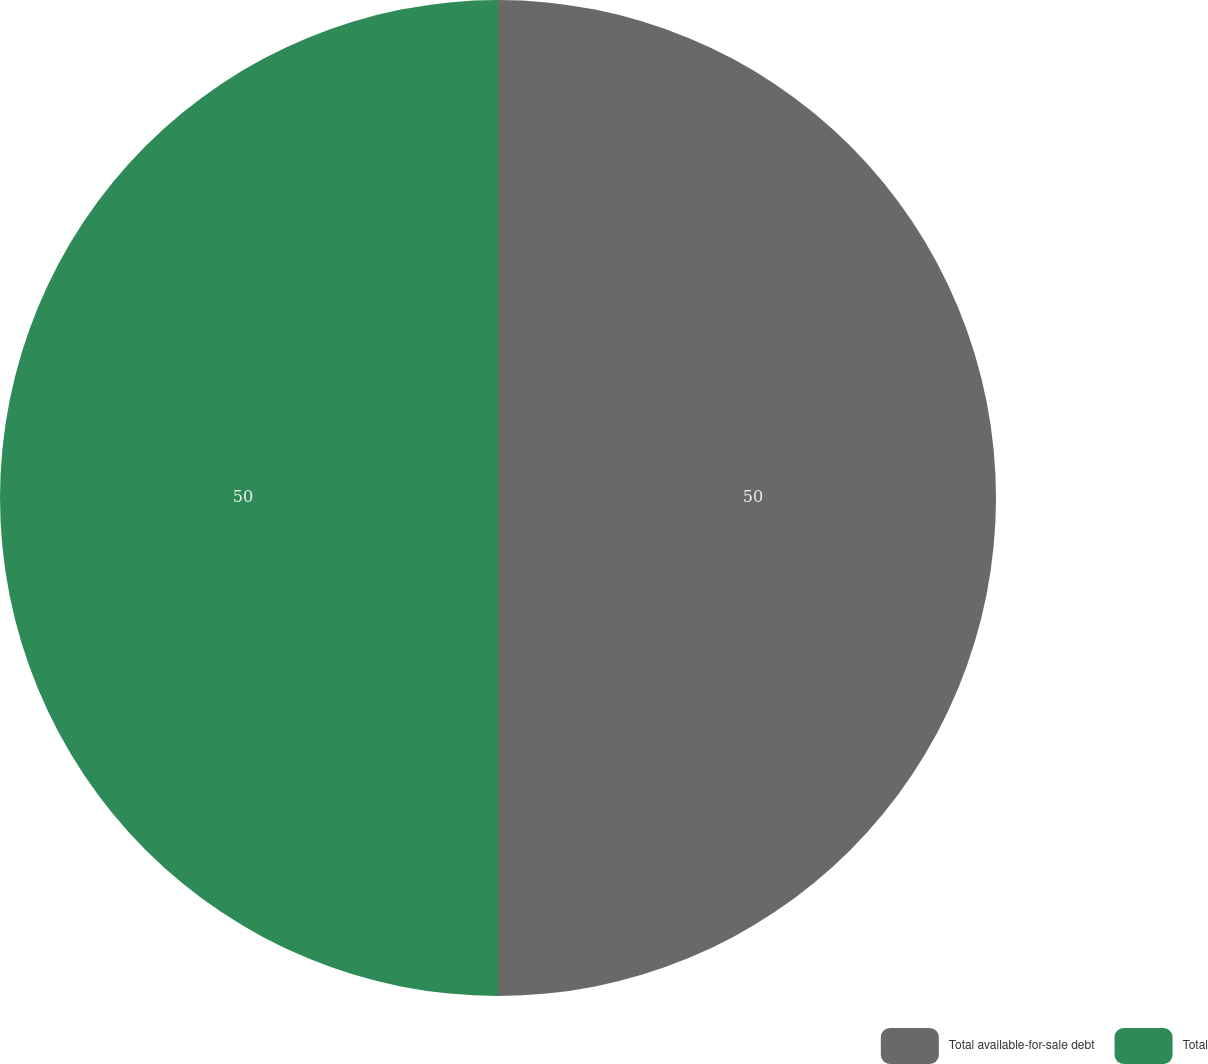Convert chart to OTSL. <chart><loc_0><loc_0><loc_500><loc_500><pie_chart><fcel>Total available-for-sale debt<fcel>Total<nl><fcel>50.0%<fcel>50.0%<nl></chart> 